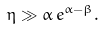Convert formula to latex. <formula><loc_0><loc_0><loc_500><loc_500>\eta \gg \alpha \, e ^ { \alpha - \beta } .</formula> 